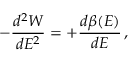<formula> <loc_0><loc_0><loc_500><loc_500>- { \frac { d ^ { 2 } W } { d E ^ { 2 } } } = + { \frac { d \beta ( E ) } { d E } } \, ,</formula> 